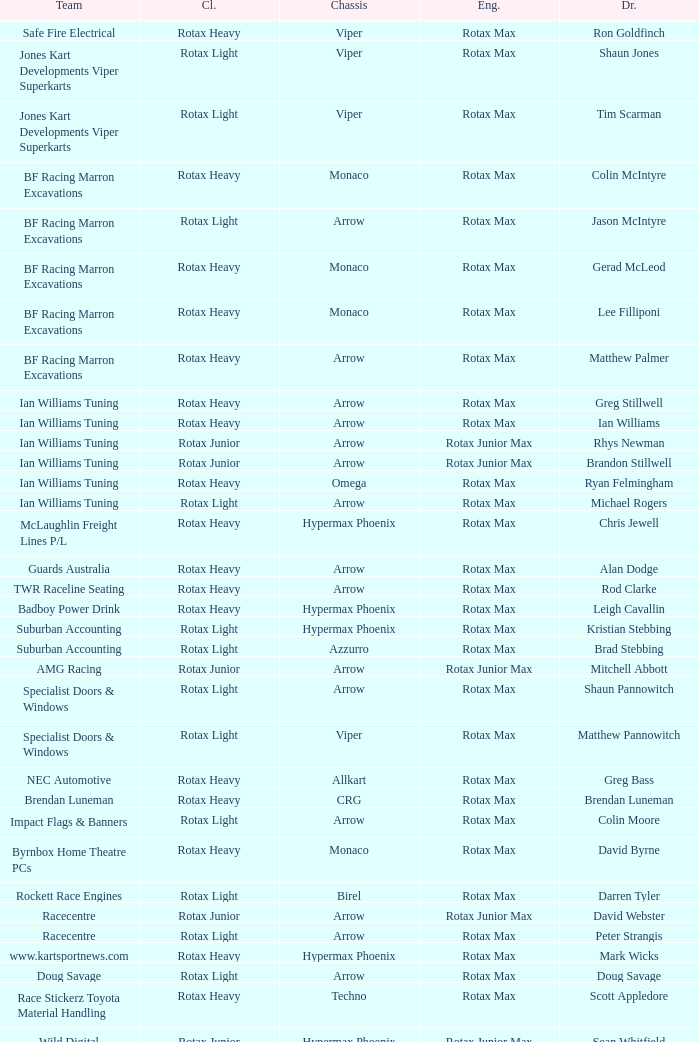Which team does Colin Moore drive for? Impact Flags & Banners. 